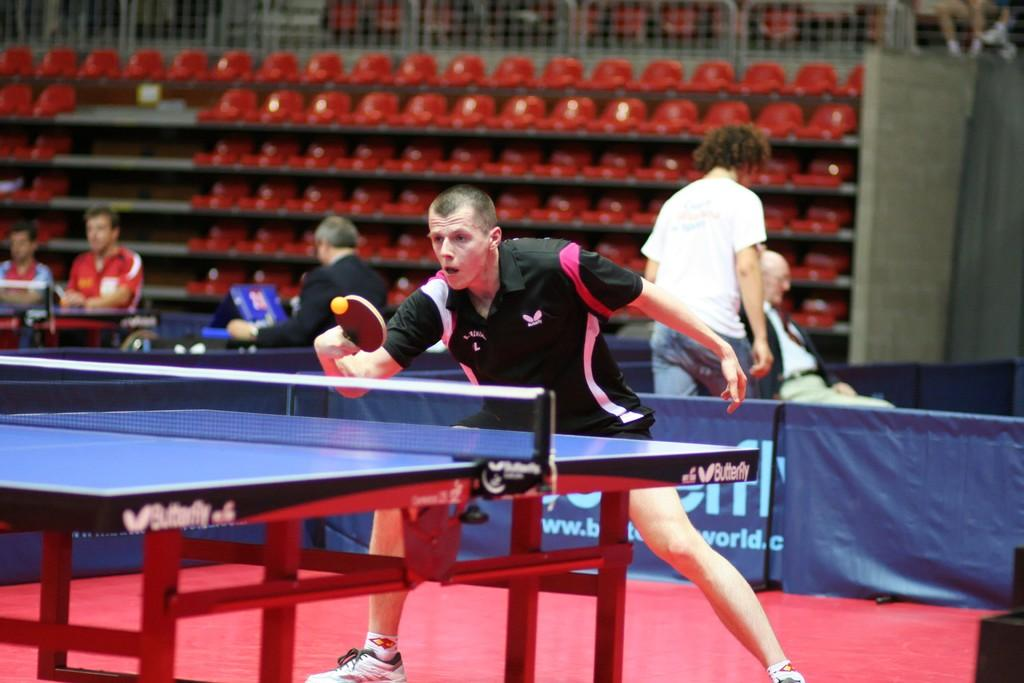What activity are the players engaged in within the image? The players are playing table tennis in the image. Can you describe the actions of the other individuals in the image? There is a man sitting and another man walking in the image. What is the color of the carpet in the image? The carpet is red. What is the color of the flexi in the image? The flexi is blue. How much tax is being paid by the players in the image? There is no information about tax in the image, as it focuses on the activity of table tennis and the actions of the individuals present. 